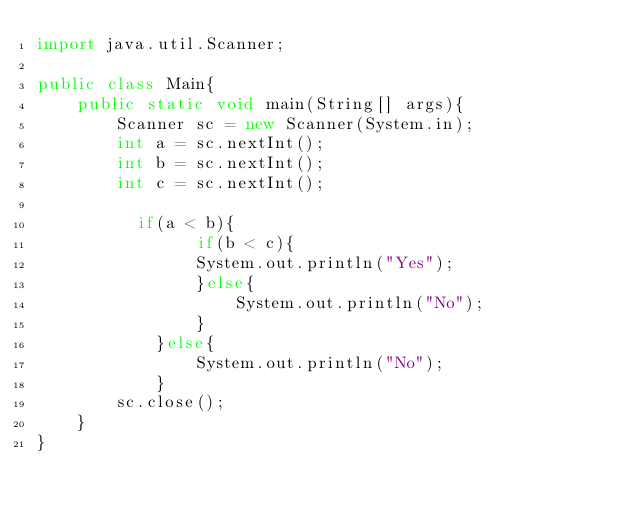Convert code to text. <code><loc_0><loc_0><loc_500><loc_500><_Java_>import java.util.Scanner;

public class Main{
    public static void main(String[] args){
        Scanner sc = new Scanner(System.in);
        int a = sc.nextInt();
        int b = sc.nextInt();
        int c = sc.nextInt();
        
        	if(a < b){
                if(b < c){
                System.out.println("Yes");
                }else{
                    System.out.println("No");
                }
            }else{
                System.out.println("No");
            }
        sc.close();
    }
}
</code> 